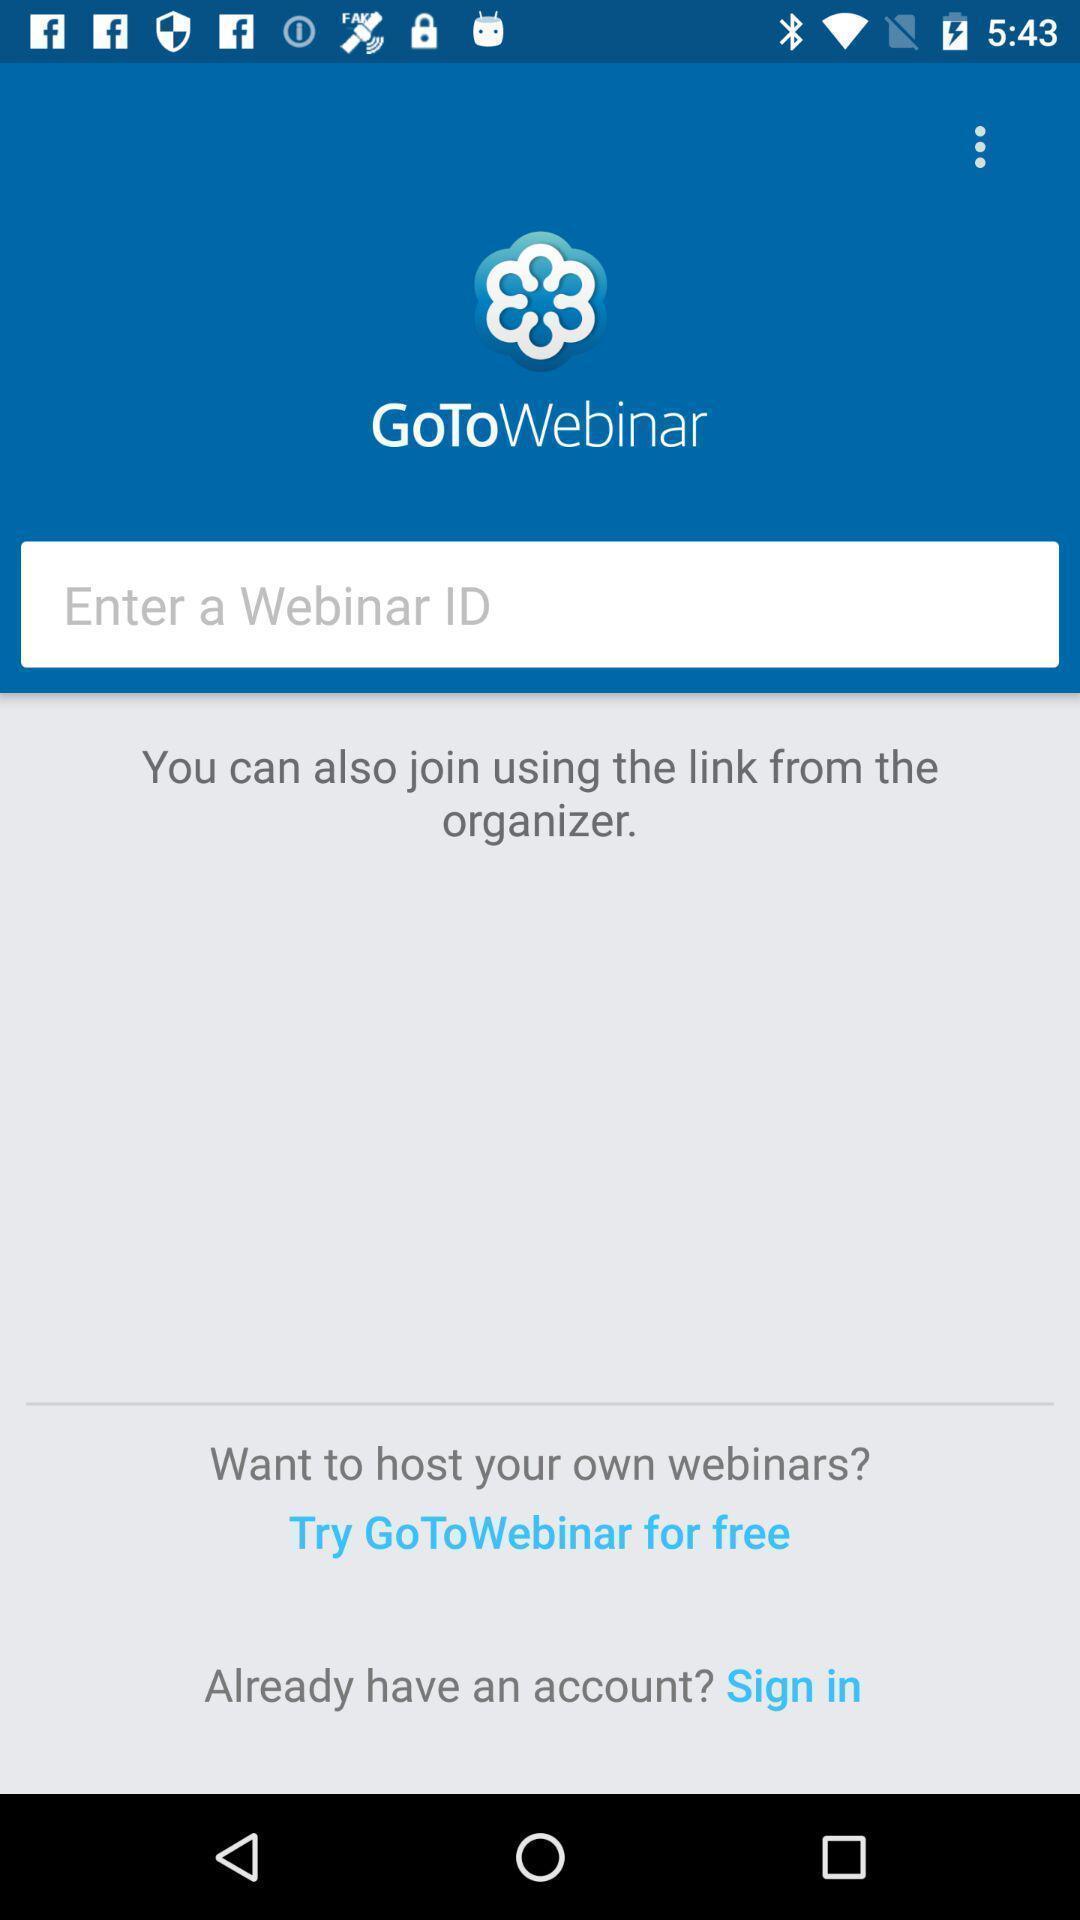Give me a summary of this screen capture. Sign in page. 